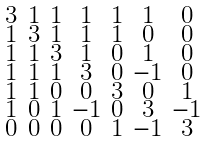Convert formula to latex. <formula><loc_0><loc_0><loc_500><loc_500>\begin{smallmatrix} 3 & 1 & 1 & 1 & 1 & 1 & 0 \\ 1 & 3 & 1 & 1 & 1 & 0 & 0 \\ 1 & 1 & 3 & 1 & 0 & 1 & 0 \\ 1 & 1 & 1 & 3 & 0 & - 1 & 0 \\ 1 & 1 & 0 & 0 & 3 & 0 & 1 \\ 1 & 0 & 1 & - 1 & 0 & 3 & - 1 \\ 0 & 0 & 0 & 0 & 1 & - 1 & 3 \end{smallmatrix}</formula> 